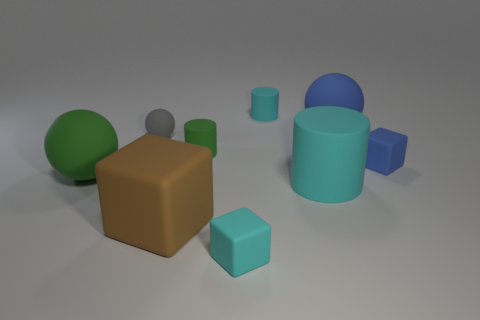Does the big cyan rubber thing have the same shape as the tiny green object?
Offer a terse response. Yes. Is there any other thing that is the same size as the brown object?
Your response must be concise. Yes. There is a green rubber thing that is the same shape as the large cyan matte thing; what is its size?
Make the answer very short. Small. Are there more small matte cubes that are on the right side of the cyan rubber cube than cyan rubber cylinders in front of the large brown object?
Provide a succinct answer. Yes. Is the material of the large brown object the same as the cyan cylinder that is behind the tiny gray matte thing?
Your answer should be very brief. Yes. There is a ball that is behind the large green matte thing and on the left side of the tiny cyan block; what color is it?
Your response must be concise. Gray. The rubber object that is behind the blue rubber ball has what shape?
Keep it short and to the point. Cylinder. There is a cube left of the tiny cyan block in front of the green matte cylinder that is behind the big rubber block; how big is it?
Offer a very short reply. Large. What number of matte things are on the right side of the ball that is right of the tiny green object?
Offer a very short reply. 1. There is a cyan rubber thing that is in front of the gray thing and behind the small cyan matte block; what size is it?
Your answer should be very brief. Large. 